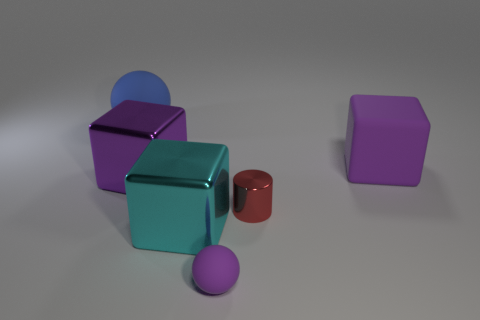There is a sphere that is the same color as the big rubber block; what is it made of?
Your response must be concise. Rubber. Do the large metallic block behind the metal cylinder and the small object in front of the small metallic object have the same color?
Provide a short and direct response. Yes. How many yellow objects are big shiny cubes or small rubber things?
Ensure brevity in your answer.  0. What color is the big sphere?
Your answer should be compact. Blue. Are there fewer blue matte things that are in front of the big ball than tiny metallic objects that are to the right of the tiny purple thing?
Offer a terse response. Yes. There is a rubber object that is both on the left side of the small red shiny cylinder and on the right side of the large blue matte ball; what shape is it?
Make the answer very short. Sphere. What number of other big things have the same shape as the big blue rubber object?
Keep it short and to the point. 0. The purple cube that is the same material as the small red cylinder is what size?
Your response must be concise. Large. How many matte spheres are the same size as the red cylinder?
Your answer should be compact. 1. There is a metallic object that is the same color as the large matte cube; what is its size?
Keep it short and to the point. Large. 